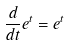Convert formula to latex. <formula><loc_0><loc_0><loc_500><loc_500>\frac { d } { d t } e ^ { t } = e ^ { t }</formula> 